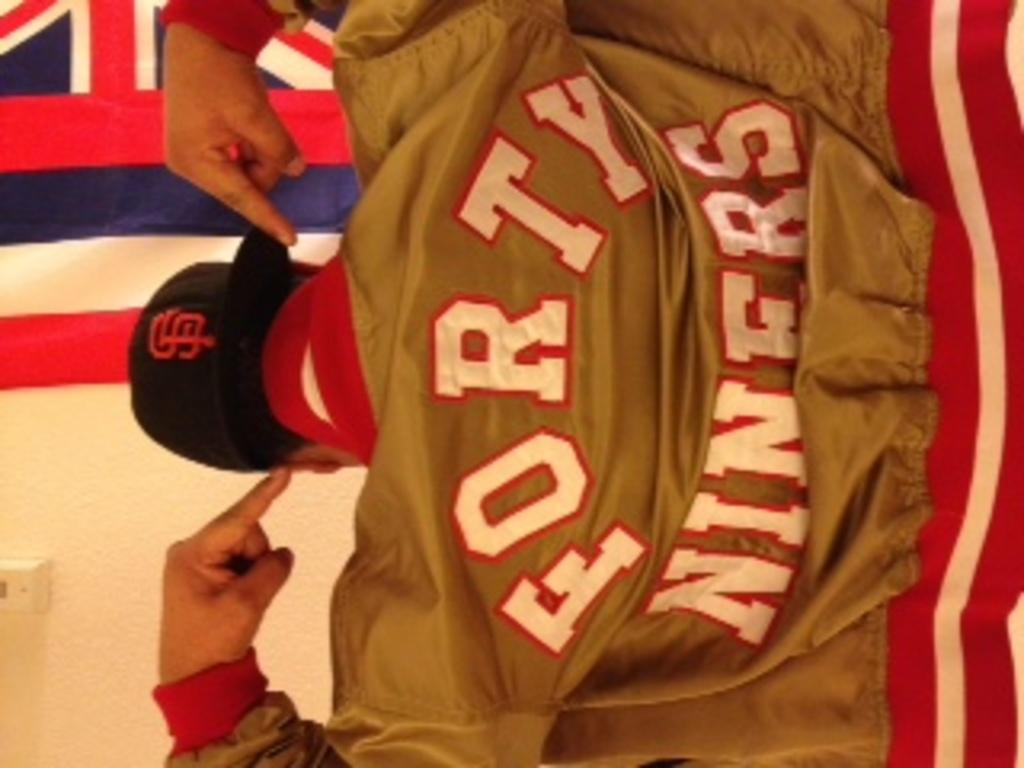<image>
Relay a brief, clear account of the picture shown. A man sits with his back to us and points to the Forty Niners wording on the back of his jacket. 